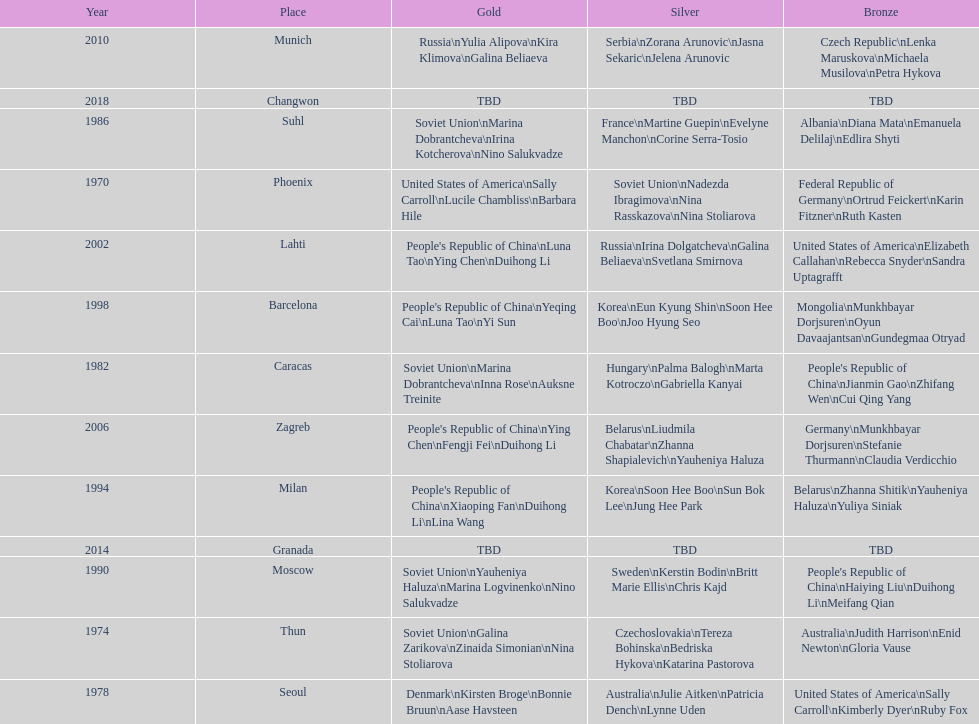Which country is listed the most under the silver column? Korea. 